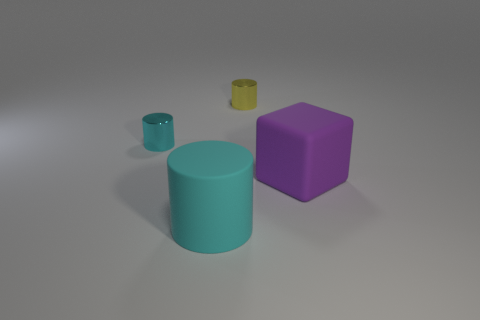Subtract all big rubber cylinders. How many cylinders are left? 2 Subtract all cyan balls. How many cyan cylinders are left? 2 Add 1 large cyan rubber cylinders. How many objects exist? 5 Subtract 1 cylinders. How many cylinders are left? 2 Subtract all cylinders. How many objects are left? 1 Subtract all purple cylinders. Subtract all gray spheres. How many cylinders are left? 3 Subtract all large rubber blocks. Subtract all large cyan matte cylinders. How many objects are left? 2 Add 4 tiny objects. How many tiny objects are left? 6 Add 1 big red metal cylinders. How many big red metal cylinders exist? 1 Subtract 0 blue balls. How many objects are left? 4 